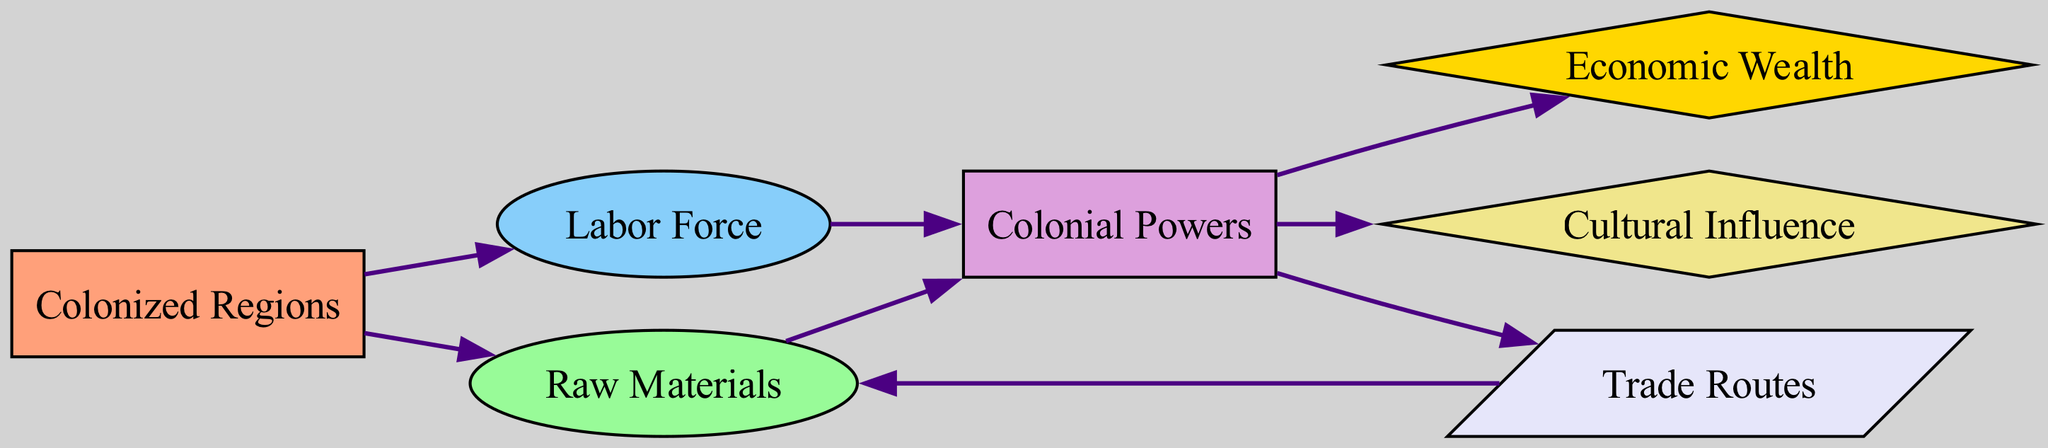What are the two types of resources highlighted in the diagram? The diagram indicates that two types of resources flow from the Colonized Regions to the Colonial Powers: Raw Materials and Labor Force. These are represented as nodes connected directly to the Colonized Regions node.
Answer: Raw Materials, Labor Force How many nodes are there in total? In the diagram, there are seven identifiable nodes: Colonized Regions, Raw Materials, Labor Force, Colonial Powers, Economic Wealth, Cultural Influence, and Trade Routes, which totals to seven.
Answer: Seven What directly leads to Economic Wealth? Economic Wealth is reached through a direct edge from the Colonial Powers node. The Colonial Powers gain Economic Wealth as a result of the processes following the receipt of resources from Colonized Regions.
Answer: Colonial Powers Which node does Trade Routes lead to? The Trade Routes node has a directed edge leading back to the Raw Materials node, indicating that Trade Routes facilitate the movement of Raw Materials.
Answer: Raw Materials What is the relationship between Colonial Powers and Cultural Influence? The relationship indicated by the directed edge shows that Colonial Powers exert Cultural Influence as one of the outcomes of their activities, signifying a flow from the Colonial Powers to Cultural Influence.
Answer: Colonial Powers What is the flow direction from Colonized Regions to Colonial Powers? The direction of flow from Colonized Regions to Colonial Powers is evident through two directed edges; one direct edge represents Raw Materials and the other represents Labor Force, both of which contribute to the Colonial Powers.
Answer: Raw Materials, Labor Force How many edges are present in the diagram? By counting the directed edges connecting the nodes, there are a total of eight edges that illustrate the flow of resources and influence throughout the graph.
Answer: Eight What node is the source of both Raw Materials and Labor Force? The source of both types of resources is the Colonized Regions node, as indicated by the directed edges leading from this node to both Raw Materials and Labor Force nodes.
Answer: Colonized Regions 